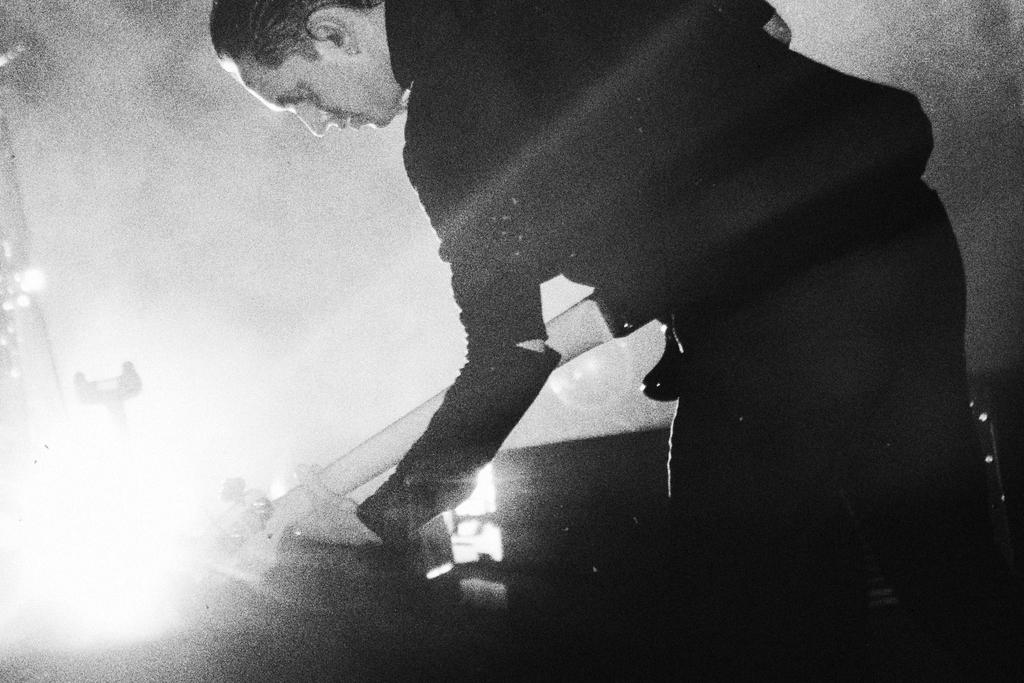What is the color scheme of the image? The image is in black and white. Can you describe the main subject in the image? There is a person in the image. What is the person doing in the image? The person is standing and playing a guitar. What type of creature is sitting on the person's shoulder in the image? There is no creature present on the person's shoulder in the image. Can you describe the feathers on the creature in the image? There is no creature with feathers present in the image. 